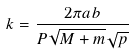<formula> <loc_0><loc_0><loc_500><loc_500>k = \frac { 2 \pi a b } { P \sqrt { M + m } \sqrt { p } }</formula> 